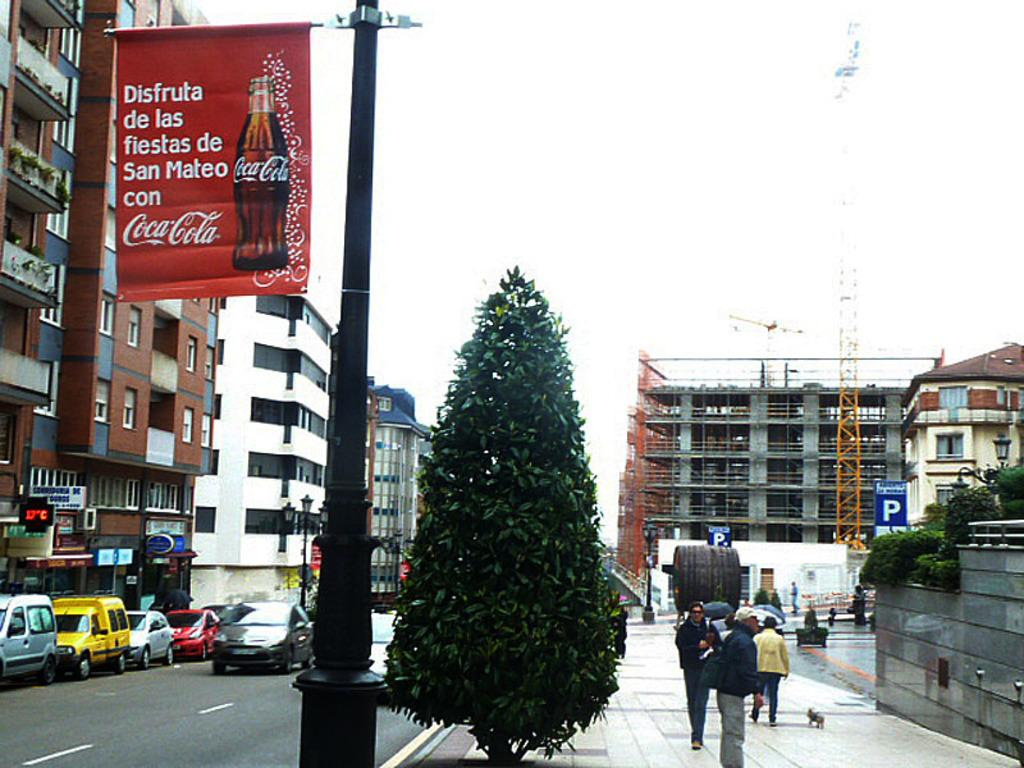Provide a one-sentence caption for the provided image. A Coca Cola banner attached to a light pole references the city of San Mateo. 